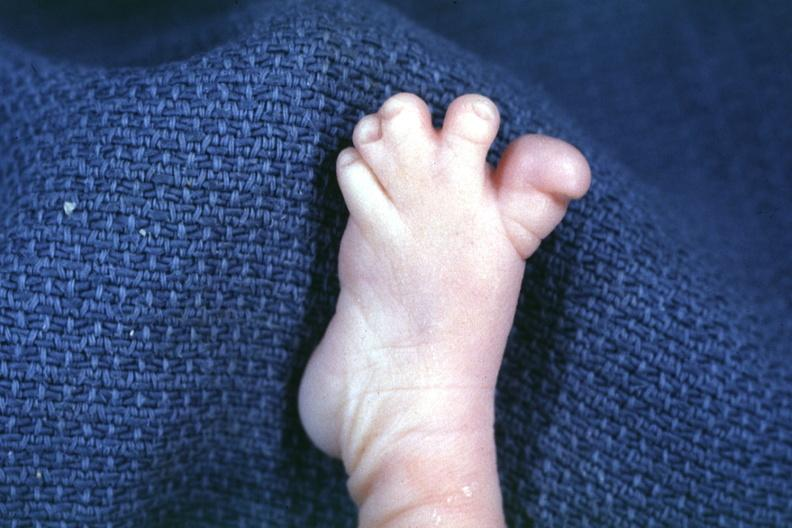what are present?
Answer the question using a single word or phrase. Extremities 